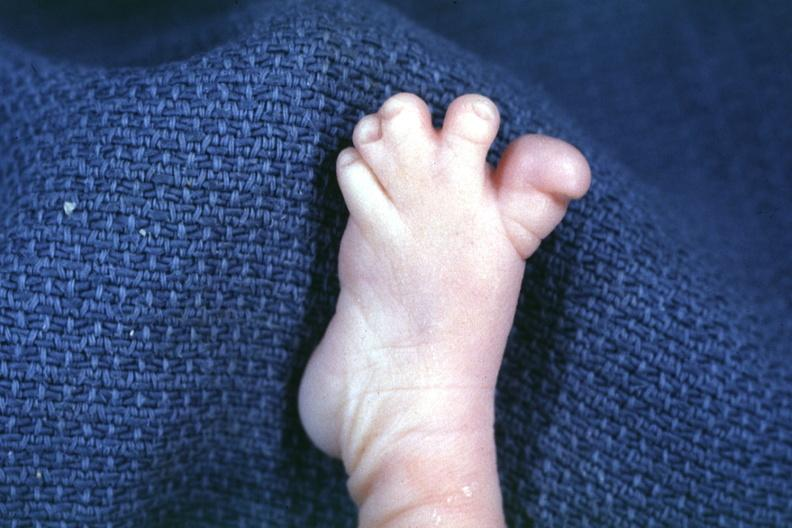what are present?
Answer the question using a single word or phrase. Extremities 